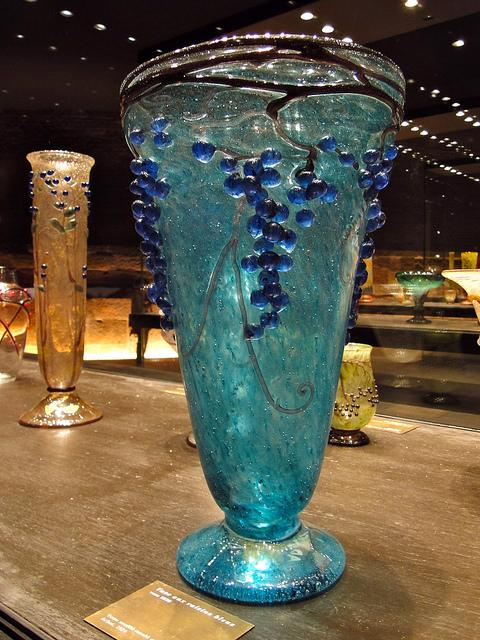What venue is this likely to be? Please explain your reasoning. art gallery. Decorative items are on display in a large indoor area. 